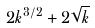Convert formula to latex. <formula><loc_0><loc_0><loc_500><loc_500>2 k ^ { 3 / 2 } + 2 \sqrt { k }</formula> 